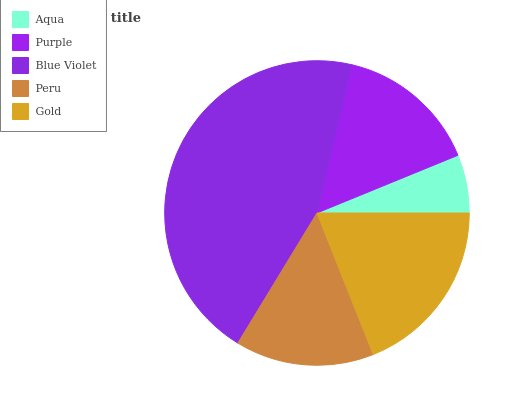Is Aqua the minimum?
Answer yes or no. Yes. Is Blue Violet the maximum?
Answer yes or no. Yes. Is Purple the minimum?
Answer yes or no. No. Is Purple the maximum?
Answer yes or no. No. Is Purple greater than Aqua?
Answer yes or no. Yes. Is Aqua less than Purple?
Answer yes or no. Yes. Is Aqua greater than Purple?
Answer yes or no. No. Is Purple less than Aqua?
Answer yes or no. No. Is Purple the high median?
Answer yes or no. Yes. Is Purple the low median?
Answer yes or no. Yes. Is Gold the high median?
Answer yes or no. No. Is Gold the low median?
Answer yes or no. No. 